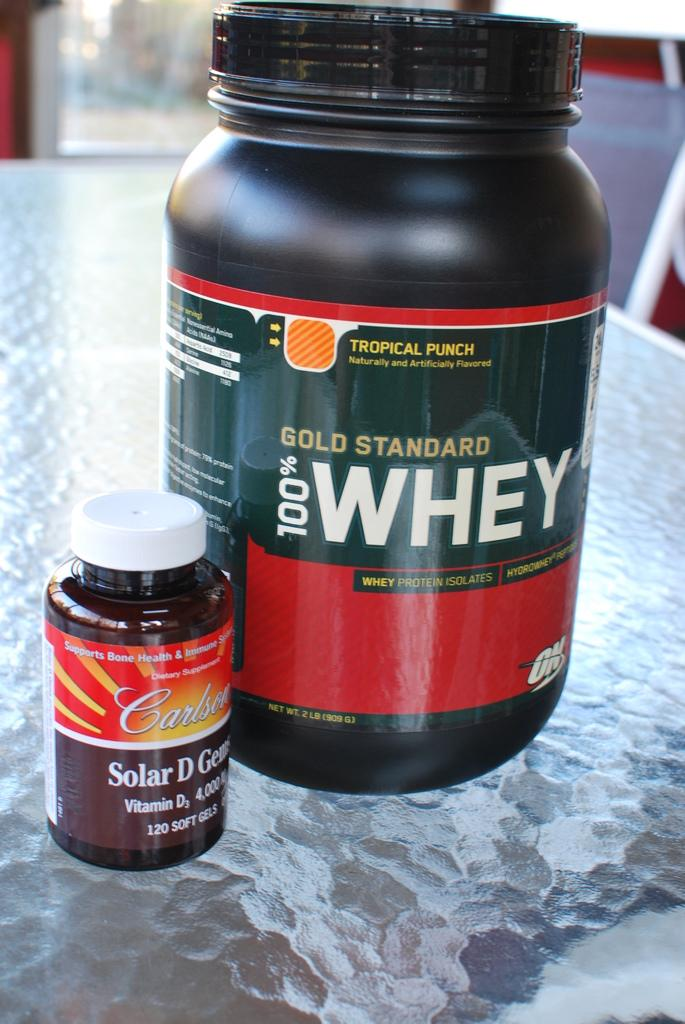<image>
Present a compact description of the photo's key features. A plastic bottle of Whey protein placed next to a smaller bottle of a vitamin supplement. 